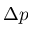Convert formula to latex. <formula><loc_0><loc_0><loc_500><loc_500>\Delta p</formula> 